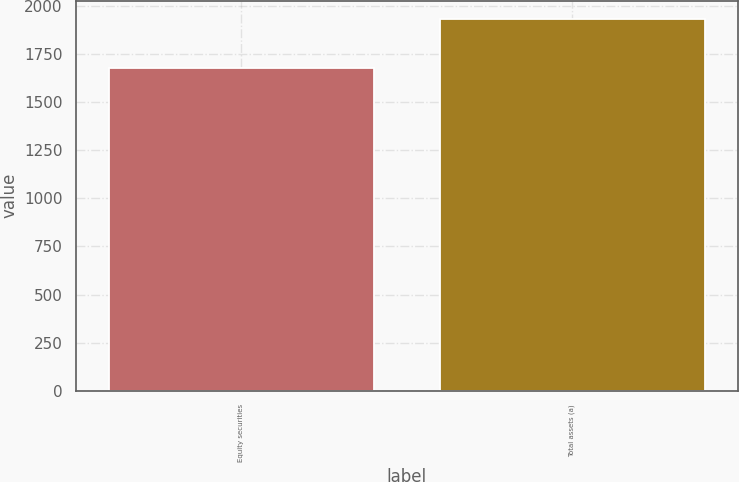Convert chart to OTSL. <chart><loc_0><loc_0><loc_500><loc_500><bar_chart><fcel>Equity securities<fcel>Total assets (a)<nl><fcel>1677<fcel>1929<nl></chart> 